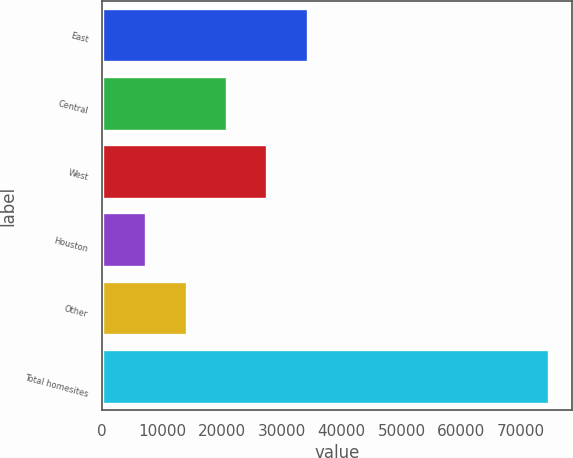Convert chart. <chart><loc_0><loc_0><loc_500><loc_500><bar_chart><fcel>East<fcel>Central<fcel>West<fcel>Houston<fcel>Other<fcel>Total homesites<nl><fcel>34305.8<fcel>20847.4<fcel>27576.6<fcel>7389<fcel>14118.2<fcel>74681<nl></chart> 